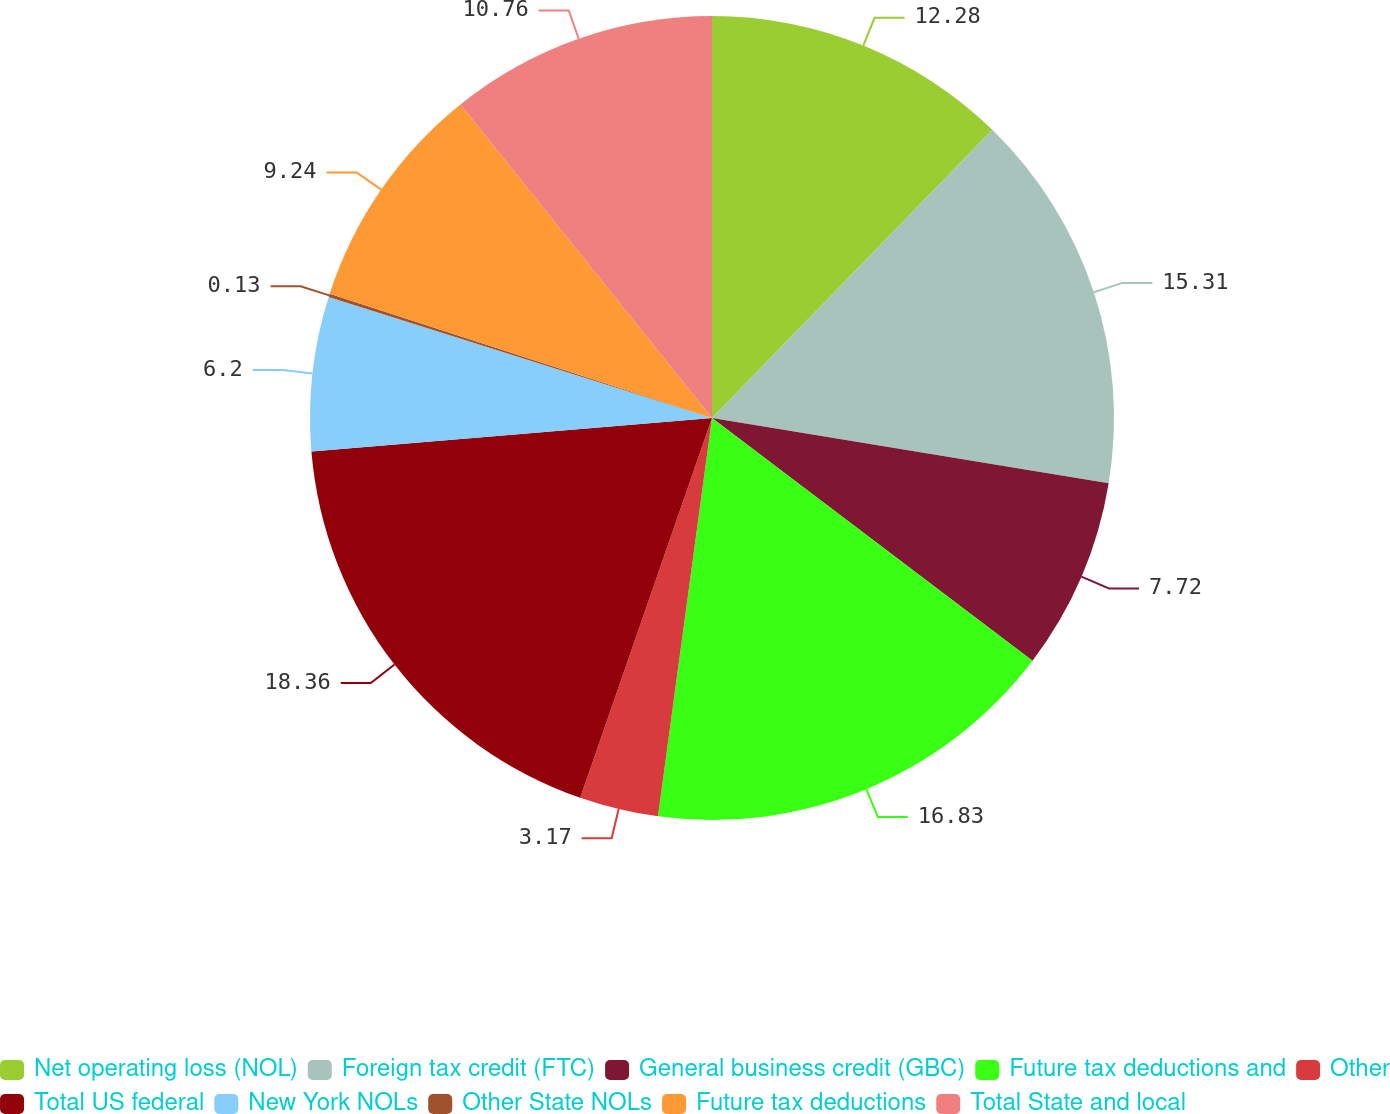Convert chart to OTSL. <chart><loc_0><loc_0><loc_500><loc_500><pie_chart><fcel>Net operating loss (NOL)<fcel>Foreign tax credit (FTC)<fcel>General business credit (GBC)<fcel>Future tax deductions and<fcel>Other<fcel>Total US federal<fcel>New York NOLs<fcel>Other State NOLs<fcel>Future tax deductions<fcel>Total State and local<nl><fcel>12.28%<fcel>15.31%<fcel>7.72%<fcel>16.83%<fcel>3.17%<fcel>18.35%<fcel>6.2%<fcel>0.13%<fcel>9.24%<fcel>10.76%<nl></chart> 